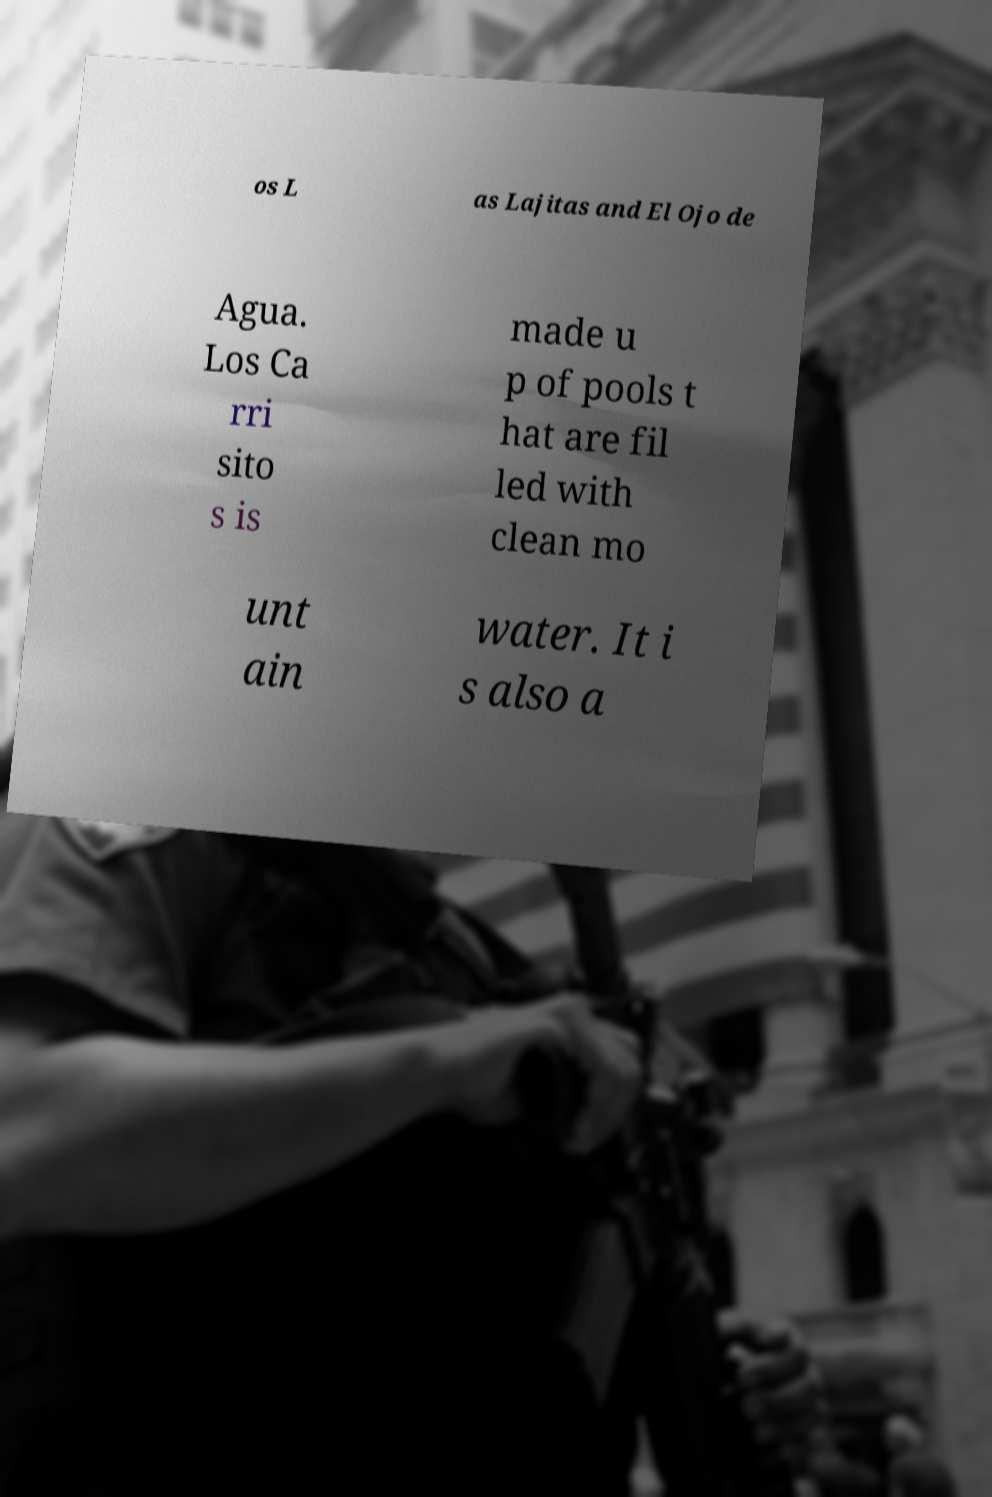There's text embedded in this image that I need extracted. Can you transcribe it verbatim? os L as Lajitas and El Ojo de Agua. Los Ca rri sito s is made u p of pools t hat are fil led with clean mo unt ain water. It i s also a 